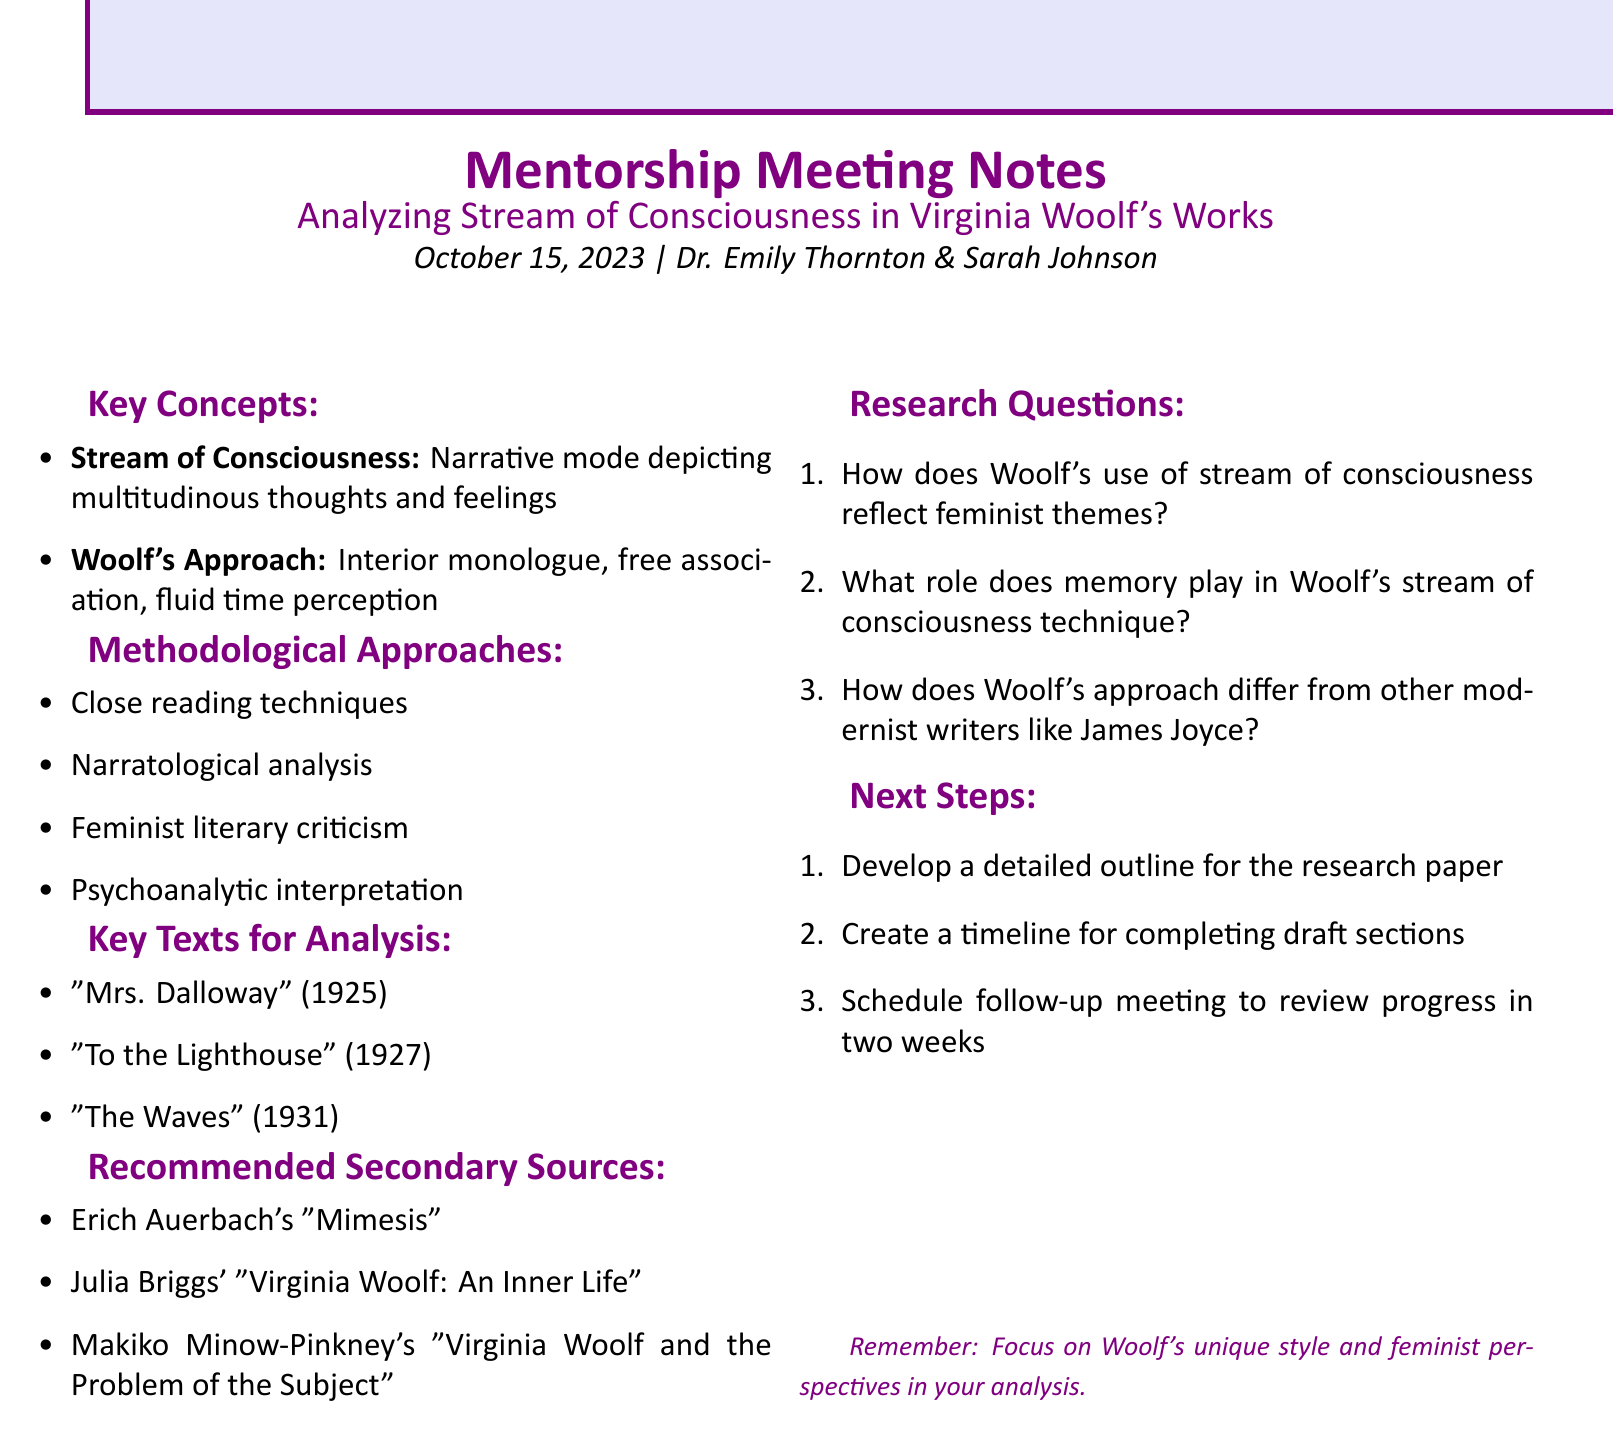What is the date of the meeting? The date of the meeting is explicitly stated in the document as October 15, 2023.
Answer: October 15, 2023 Who is the mentor? The mentor's name is listed as Dr. Emily Thornton in the meeting details.
Answer: Dr. Emily Thornton What narrative mode does Woolf use? The document defines stream of consciousness as a narrative mode depicting multitudinous thoughts and feelings.
Answer: Stream of consciousness Name one methodological approach mentioned. The document lists several methodological approaches, including close reading techniques, which is one of them.
Answer: Close reading techniques What is one of the key texts for analysis? The document provides a list of key texts, including "Mrs. Dalloway," which is mentioned as a significant work for analysis.
Answer: "Mrs. Dalloway" How many research questions are listed? The document enumerates three research questions under the research questions section.
Answer: Three What is the next step related to the paper's outline? The document mentions developing a detailed outline for the research paper as a next step.
Answer: Develop a detailed outline What is a recommended secondary source? The document refers to Julia Briggs' "Virginia Woolf: An Inner Life" as one of the recommended secondary sources.
Answer: Julia Briggs' "Virginia Woolf: An Inner Life" Which literary perspective is suggested for analyzing Woolf's works? The document highlights feminist literary criticism as one of the methodological approaches.
Answer: Feminist literary criticism 